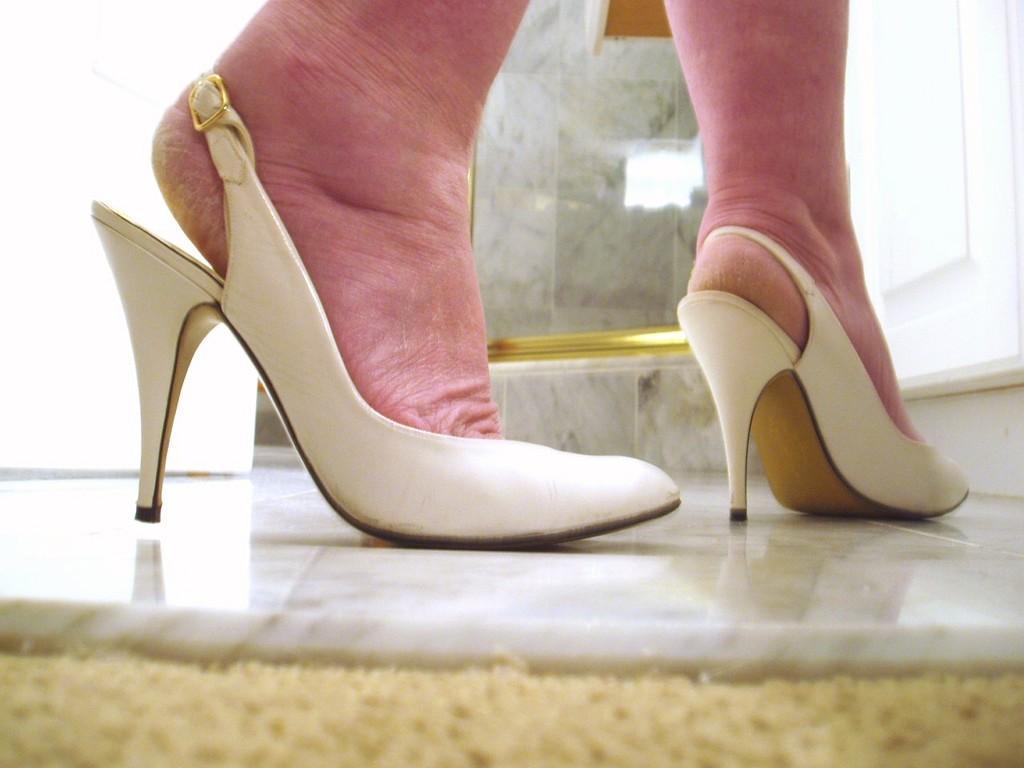Could you give a brief overview of what you see in this image? In the center of the image we can see a person legs and wearing heels. In the background of the image we can see wall, glass, door. At the bottom of the image there is a floor. 